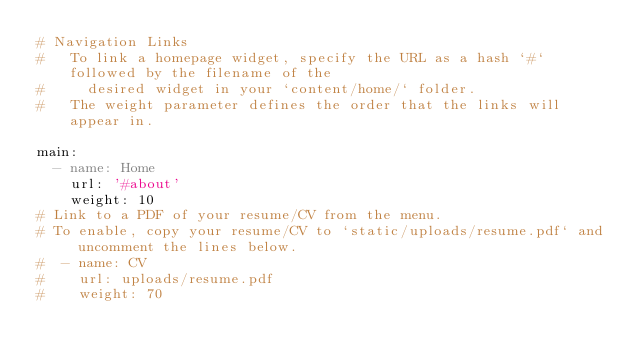Convert code to text. <code><loc_0><loc_0><loc_500><loc_500><_YAML_># Navigation Links
#   To link a homepage widget, specify the URL as a hash `#` followed by the filename of the
#     desired widget in your `content/home/` folder.
#   The weight parameter defines the order that the links will appear in.

main:
  - name: Home
    url: '#about'
    weight: 10
# Link to a PDF of your resume/CV from the menu.
# To enable, copy your resume/CV to `static/uploads/resume.pdf` and uncomment the lines below.
#  - name: CV
#    url: uploads/resume.pdf
#    weight: 70
</code> 